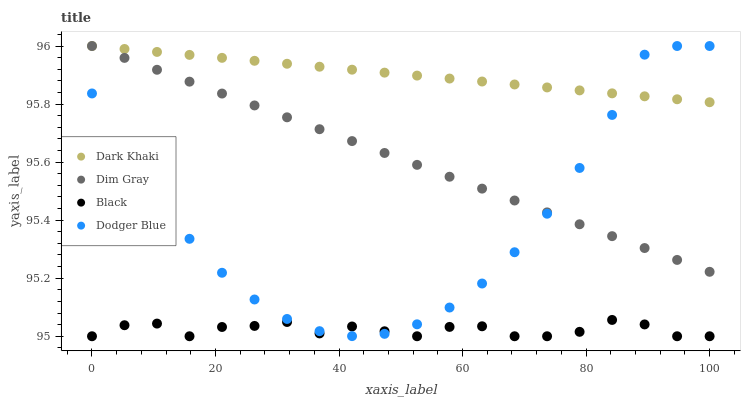Does Black have the minimum area under the curve?
Answer yes or no. Yes. Does Dark Khaki have the maximum area under the curve?
Answer yes or no. Yes. Does Dodger Blue have the minimum area under the curve?
Answer yes or no. No. Does Dodger Blue have the maximum area under the curve?
Answer yes or no. No. Is Dark Khaki the smoothest?
Answer yes or no. Yes. Is Black the roughest?
Answer yes or no. Yes. Is Dodger Blue the smoothest?
Answer yes or no. No. Is Dodger Blue the roughest?
Answer yes or no. No. Does Black have the lowest value?
Answer yes or no. Yes. Does Dodger Blue have the lowest value?
Answer yes or no. No. Does Dim Gray have the highest value?
Answer yes or no. Yes. Does Black have the highest value?
Answer yes or no. No. Is Black less than Dim Gray?
Answer yes or no. Yes. Is Dark Khaki greater than Black?
Answer yes or no. Yes. Does Dim Gray intersect Dark Khaki?
Answer yes or no. Yes. Is Dim Gray less than Dark Khaki?
Answer yes or no. No. Is Dim Gray greater than Dark Khaki?
Answer yes or no. No. Does Black intersect Dim Gray?
Answer yes or no. No. 